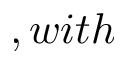Convert formula to latex. <formula><loc_0><loc_0><loc_500><loc_500>, w i t h</formula> 